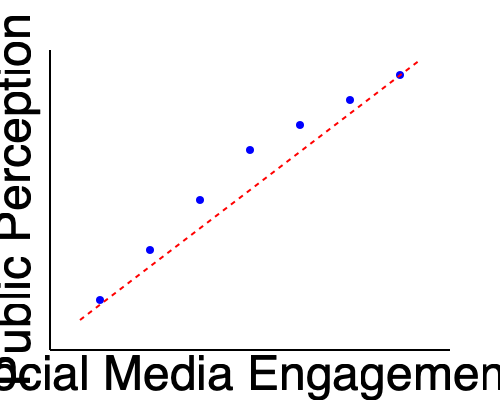As a PR consultant in the science sector, how would you interpret the relationship between social media engagement and public perception of scientific breakthroughs based on the scatter plot? What strategy would you recommend to improve public perception? To interpret the scatter plot and recommend a strategy, we need to follow these steps:

1. Analyze the trend:
   The scatter plot shows a clear negative correlation between social media engagement and public perception of scientific breakthroughs. As social media engagement increases, public perception tends to decrease.

2. Interpret the correlation:
   This negative correlation suggests that higher social media engagement might be associated with lower public perception of scientific breakthroughs. This could be due to factors such as:
   a) Oversimplification of complex scientific concepts on social media
   b) Spread of misinformation or sensationalized content
   c) Lack of context or nuance in social media discussions

3. Consider the limitations:
   It's important to note that correlation does not imply causation. Other factors may be influencing both variables.

4. Develop a strategy:
   Given the negative correlation, a strategy to improve public perception while maintaining social media engagement could include:
   a) Creating high-quality, accurate content that explains scientific breakthroughs in accessible language
   b) Engaging with credible scientists and institutions to share and validate information
   c) Implementing fact-checking mechanisms and addressing misinformation promptly
   d) Encouraging meaningful discussions and providing additional resources for in-depth understanding
   e) Using social media to direct audience to more comprehensive, authoritative sources

5. Monitor and adjust:
   Continuously track the impact of the strategy on both social media engagement and public perception, adjusting tactics as necessary to maintain a balance between reach and accuracy.
Answer: Implement a strategy focusing on high-quality, accurate content creation and collaboration with credible sources to improve public perception while maintaining social media engagement. 